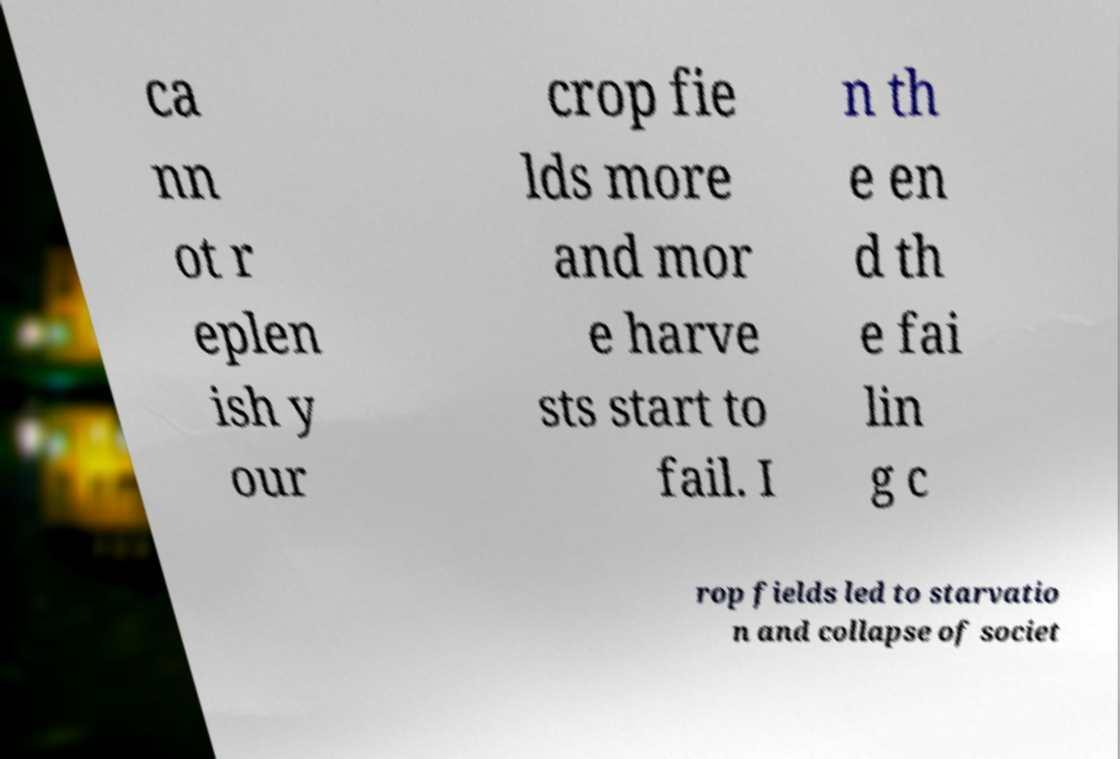Please identify and transcribe the text found in this image. ca nn ot r eplen ish y our crop fie lds more and mor e harve sts start to fail. I n th e en d th e fai lin g c rop fields led to starvatio n and collapse of societ 